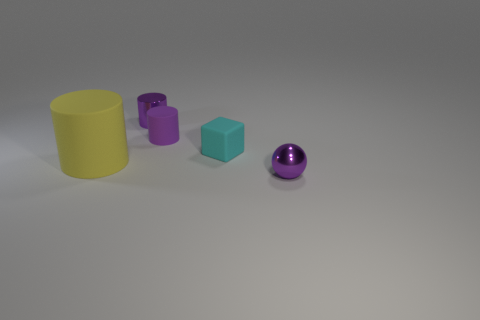What shape is the rubber object that is the same color as the tiny metal cylinder?
Offer a very short reply. Cylinder. There is a purple metal thing that is left of the small purple metal object that is in front of the large yellow thing; what is its size?
Offer a terse response. Small. There is a metallic cylinder that is the same color as the ball; what is its size?
Ensure brevity in your answer.  Small. How many other objects are the same size as the shiny ball?
Offer a very short reply. 3. What is the color of the rubber cylinder that is left of the metallic thing to the left of the purple shiny object that is to the right of the tiny rubber cube?
Keep it short and to the point. Yellow. How many other things are the same shape as the yellow object?
Provide a short and direct response. 2. What is the shape of the metal object to the right of the cube?
Keep it short and to the point. Sphere. There is a small purple metal object in front of the shiny cylinder; is there a big matte object that is on the left side of it?
Offer a terse response. Yes. The thing that is on the left side of the small rubber cylinder and in front of the small matte cube is what color?
Offer a terse response. Yellow. Are there any small cylinders that are behind the purple cylinder that is in front of the tiny purple object left of the tiny matte cylinder?
Ensure brevity in your answer.  Yes. 